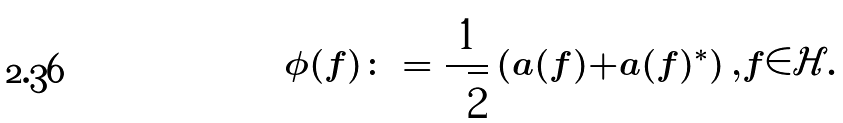<formula> <loc_0><loc_0><loc_500><loc_500>\phi ( f ) \colon = \frac { 1 } { \sqrt { 2 } } \left ( a ( f ) + a ( f ) ^ { * } \right ) , f \in \mathcal { H } .</formula> 